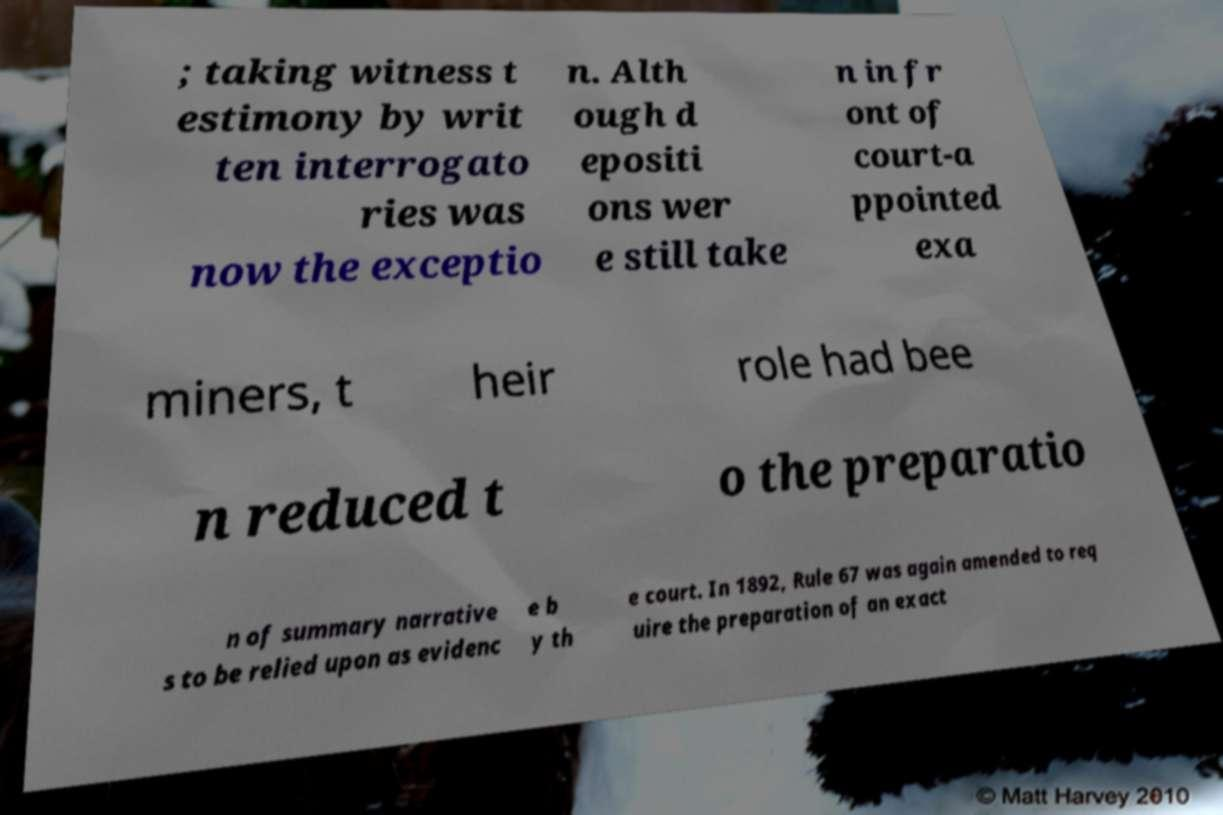Could you extract and type out the text from this image? ; taking witness t estimony by writ ten interrogato ries was now the exceptio n. Alth ough d epositi ons wer e still take n in fr ont of court-a ppointed exa miners, t heir role had bee n reduced t o the preparatio n of summary narrative s to be relied upon as evidenc e b y th e court. In 1892, Rule 67 was again amended to req uire the preparation of an exact 